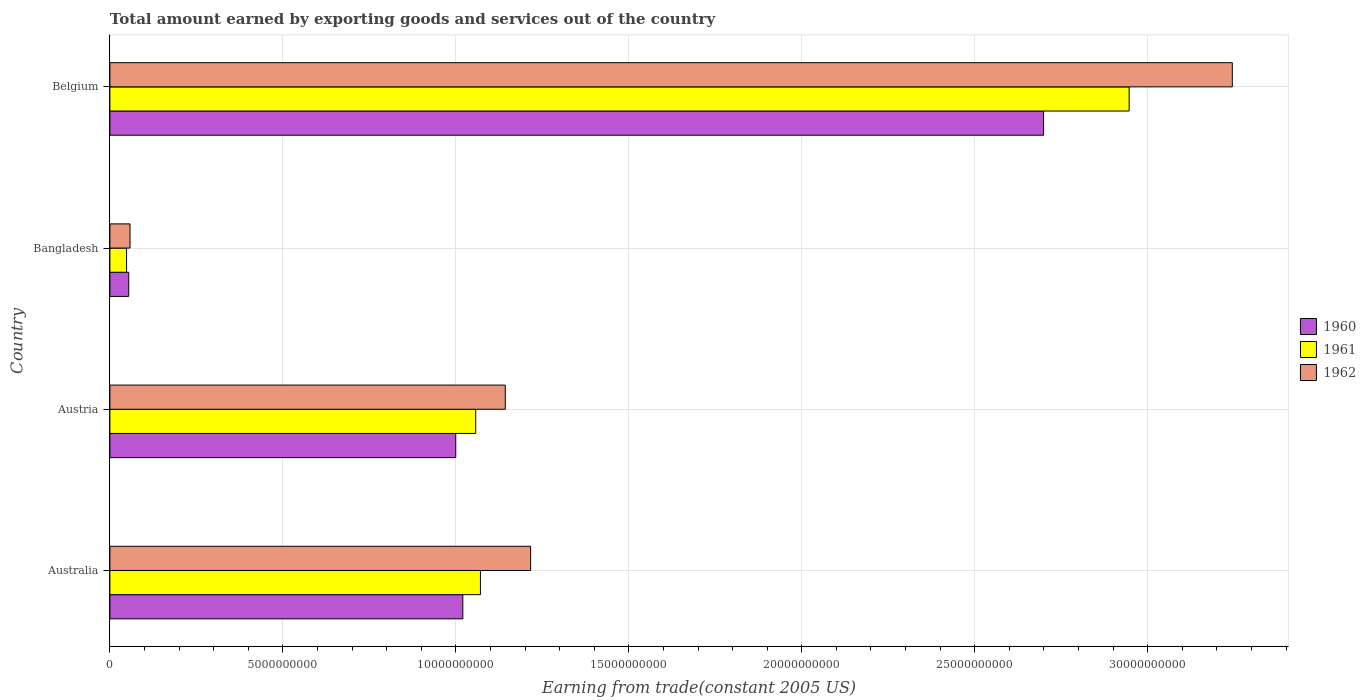How many different coloured bars are there?
Offer a very short reply. 3. How many groups of bars are there?
Give a very brief answer. 4. Are the number of bars on each tick of the Y-axis equal?
Offer a very short reply. Yes. How many bars are there on the 3rd tick from the top?
Your response must be concise. 3. What is the label of the 3rd group of bars from the top?
Your answer should be very brief. Austria. In how many cases, is the number of bars for a given country not equal to the number of legend labels?
Keep it short and to the point. 0. What is the total amount earned by exporting goods and services in 1961 in Australia?
Offer a terse response. 1.07e+1. Across all countries, what is the maximum total amount earned by exporting goods and services in 1961?
Offer a terse response. 2.95e+1. Across all countries, what is the minimum total amount earned by exporting goods and services in 1961?
Ensure brevity in your answer.  4.82e+08. What is the total total amount earned by exporting goods and services in 1962 in the graph?
Your answer should be compact. 5.66e+1. What is the difference between the total amount earned by exporting goods and services in 1962 in Bangladesh and that in Belgium?
Your response must be concise. -3.19e+1. What is the difference between the total amount earned by exporting goods and services in 1960 in Bangladesh and the total amount earned by exporting goods and services in 1962 in Austria?
Your answer should be very brief. -1.09e+1. What is the average total amount earned by exporting goods and services in 1962 per country?
Offer a very short reply. 1.42e+1. What is the difference between the total amount earned by exporting goods and services in 1960 and total amount earned by exporting goods and services in 1961 in Belgium?
Offer a very short reply. -2.47e+09. In how many countries, is the total amount earned by exporting goods and services in 1962 greater than 24000000000 US$?
Offer a terse response. 1. What is the ratio of the total amount earned by exporting goods and services in 1960 in Australia to that in Austria?
Provide a short and direct response. 1.02. What is the difference between the highest and the second highest total amount earned by exporting goods and services in 1961?
Make the answer very short. 1.88e+1. What is the difference between the highest and the lowest total amount earned by exporting goods and services in 1962?
Give a very brief answer. 3.19e+1. What does the 2nd bar from the top in Australia represents?
Provide a short and direct response. 1961. Is it the case that in every country, the sum of the total amount earned by exporting goods and services in 1962 and total amount earned by exporting goods and services in 1961 is greater than the total amount earned by exporting goods and services in 1960?
Your answer should be very brief. Yes. How many bars are there?
Keep it short and to the point. 12. Are all the bars in the graph horizontal?
Your answer should be very brief. Yes. What is the difference between two consecutive major ticks on the X-axis?
Ensure brevity in your answer.  5.00e+09. Are the values on the major ticks of X-axis written in scientific E-notation?
Give a very brief answer. No. Does the graph contain any zero values?
Make the answer very short. No. Does the graph contain grids?
Ensure brevity in your answer.  Yes. Where does the legend appear in the graph?
Your answer should be compact. Center right. How many legend labels are there?
Your answer should be compact. 3. What is the title of the graph?
Make the answer very short. Total amount earned by exporting goods and services out of the country. What is the label or title of the X-axis?
Your answer should be very brief. Earning from trade(constant 2005 US). What is the Earning from trade(constant 2005 US) in 1960 in Australia?
Make the answer very short. 1.02e+1. What is the Earning from trade(constant 2005 US) in 1961 in Australia?
Provide a succinct answer. 1.07e+1. What is the Earning from trade(constant 2005 US) of 1962 in Australia?
Provide a succinct answer. 1.22e+1. What is the Earning from trade(constant 2005 US) in 1960 in Austria?
Provide a succinct answer. 1.00e+1. What is the Earning from trade(constant 2005 US) in 1961 in Austria?
Your answer should be very brief. 1.06e+1. What is the Earning from trade(constant 2005 US) in 1962 in Austria?
Offer a very short reply. 1.14e+1. What is the Earning from trade(constant 2005 US) of 1960 in Bangladesh?
Your answer should be very brief. 5.45e+08. What is the Earning from trade(constant 2005 US) of 1961 in Bangladesh?
Your response must be concise. 4.82e+08. What is the Earning from trade(constant 2005 US) of 1962 in Bangladesh?
Offer a terse response. 5.82e+08. What is the Earning from trade(constant 2005 US) in 1960 in Belgium?
Provide a short and direct response. 2.70e+1. What is the Earning from trade(constant 2005 US) in 1961 in Belgium?
Your answer should be very brief. 2.95e+1. What is the Earning from trade(constant 2005 US) of 1962 in Belgium?
Keep it short and to the point. 3.24e+1. Across all countries, what is the maximum Earning from trade(constant 2005 US) in 1960?
Offer a very short reply. 2.70e+1. Across all countries, what is the maximum Earning from trade(constant 2005 US) in 1961?
Give a very brief answer. 2.95e+1. Across all countries, what is the maximum Earning from trade(constant 2005 US) of 1962?
Offer a very short reply. 3.24e+1. Across all countries, what is the minimum Earning from trade(constant 2005 US) of 1960?
Your answer should be very brief. 5.45e+08. Across all countries, what is the minimum Earning from trade(constant 2005 US) of 1961?
Provide a short and direct response. 4.82e+08. Across all countries, what is the minimum Earning from trade(constant 2005 US) of 1962?
Offer a terse response. 5.82e+08. What is the total Earning from trade(constant 2005 US) of 1960 in the graph?
Your answer should be very brief. 4.77e+1. What is the total Earning from trade(constant 2005 US) of 1961 in the graph?
Give a very brief answer. 5.12e+1. What is the total Earning from trade(constant 2005 US) in 1962 in the graph?
Make the answer very short. 5.66e+1. What is the difference between the Earning from trade(constant 2005 US) in 1960 in Australia and that in Austria?
Your answer should be compact. 2.04e+08. What is the difference between the Earning from trade(constant 2005 US) of 1961 in Australia and that in Austria?
Your response must be concise. 1.36e+08. What is the difference between the Earning from trade(constant 2005 US) of 1962 in Australia and that in Austria?
Your response must be concise. 7.33e+08. What is the difference between the Earning from trade(constant 2005 US) of 1960 in Australia and that in Bangladesh?
Provide a succinct answer. 9.66e+09. What is the difference between the Earning from trade(constant 2005 US) in 1961 in Australia and that in Bangladesh?
Ensure brevity in your answer.  1.02e+1. What is the difference between the Earning from trade(constant 2005 US) of 1962 in Australia and that in Bangladesh?
Make the answer very short. 1.16e+1. What is the difference between the Earning from trade(constant 2005 US) of 1960 in Australia and that in Belgium?
Ensure brevity in your answer.  -1.68e+1. What is the difference between the Earning from trade(constant 2005 US) of 1961 in Australia and that in Belgium?
Offer a very short reply. -1.88e+1. What is the difference between the Earning from trade(constant 2005 US) of 1962 in Australia and that in Belgium?
Your answer should be very brief. -2.03e+1. What is the difference between the Earning from trade(constant 2005 US) of 1960 in Austria and that in Bangladesh?
Give a very brief answer. 9.45e+09. What is the difference between the Earning from trade(constant 2005 US) in 1961 in Austria and that in Bangladesh?
Keep it short and to the point. 1.01e+1. What is the difference between the Earning from trade(constant 2005 US) in 1962 in Austria and that in Bangladesh?
Your answer should be very brief. 1.08e+1. What is the difference between the Earning from trade(constant 2005 US) of 1960 in Austria and that in Belgium?
Give a very brief answer. -1.70e+1. What is the difference between the Earning from trade(constant 2005 US) in 1961 in Austria and that in Belgium?
Keep it short and to the point. -1.89e+1. What is the difference between the Earning from trade(constant 2005 US) of 1962 in Austria and that in Belgium?
Your answer should be very brief. -2.10e+1. What is the difference between the Earning from trade(constant 2005 US) of 1960 in Bangladesh and that in Belgium?
Your answer should be compact. -2.64e+1. What is the difference between the Earning from trade(constant 2005 US) in 1961 in Bangladesh and that in Belgium?
Make the answer very short. -2.90e+1. What is the difference between the Earning from trade(constant 2005 US) of 1962 in Bangladesh and that in Belgium?
Offer a terse response. -3.19e+1. What is the difference between the Earning from trade(constant 2005 US) in 1960 in Australia and the Earning from trade(constant 2005 US) in 1961 in Austria?
Give a very brief answer. -3.73e+08. What is the difference between the Earning from trade(constant 2005 US) in 1960 in Australia and the Earning from trade(constant 2005 US) in 1962 in Austria?
Your answer should be compact. -1.23e+09. What is the difference between the Earning from trade(constant 2005 US) of 1961 in Australia and the Earning from trade(constant 2005 US) of 1962 in Austria?
Keep it short and to the point. -7.18e+08. What is the difference between the Earning from trade(constant 2005 US) in 1960 in Australia and the Earning from trade(constant 2005 US) in 1961 in Bangladesh?
Give a very brief answer. 9.72e+09. What is the difference between the Earning from trade(constant 2005 US) of 1960 in Australia and the Earning from trade(constant 2005 US) of 1962 in Bangladesh?
Provide a short and direct response. 9.62e+09. What is the difference between the Earning from trade(constant 2005 US) in 1961 in Australia and the Earning from trade(constant 2005 US) in 1962 in Bangladesh?
Provide a short and direct response. 1.01e+1. What is the difference between the Earning from trade(constant 2005 US) of 1960 in Australia and the Earning from trade(constant 2005 US) of 1961 in Belgium?
Keep it short and to the point. -1.93e+1. What is the difference between the Earning from trade(constant 2005 US) in 1960 in Australia and the Earning from trade(constant 2005 US) in 1962 in Belgium?
Give a very brief answer. -2.22e+1. What is the difference between the Earning from trade(constant 2005 US) of 1961 in Australia and the Earning from trade(constant 2005 US) of 1962 in Belgium?
Keep it short and to the point. -2.17e+1. What is the difference between the Earning from trade(constant 2005 US) in 1960 in Austria and the Earning from trade(constant 2005 US) in 1961 in Bangladesh?
Keep it short and to the point. 9.52e+09. What is the difference between the Earning from trade(constant 2005 US) of 1960 in Austria and the Earning from trade(constant 2005 US) of 1962 in Bangladesh?
Provide a succinct answer. 9.42e+09. What is the difference between the Earning from trade(constant 2005 US) in 1961 in Austria and the Earning from trade(constant 2005 US) in 1962 in Bangladesh?
Ensure brevity in your answer.  9.99e+09. What is the difference between the Earning from trade(constant 2005 US) of 1960 in Austria and the Earning from trade(constant 2005 US) of 1961 in Belgium?
Give a very brief answer. -1.95e+1. What is the difference between the Earning from trade(constant 2005 US) of 1960 in Austria and the Earning from trade(constant 2005 US) of 1962 in Belgium?
Provide a succinct answer. -2.24e+1. What is the difference between the Earning from trade(constant 2005 US) in 1961 in Austria and the Earning from trade(constant 2005 US) in 1962 in Belgium?
Your answer should be very brief. -2.19e+1. What is the difference between the Earning from trade(constant 2005 US) in 1960 in Bangladesh and the Earning from trade(constant 2005 US) in 1961 in Belgium?
Your response must be concise. -2.89e+1. What is the difference between the Earning from trade(constant 2005 US) of 1960 in Bangladesh and the Earning from trade(constant 2005 US) of 1962 in Belgium?
Offer a very short reply. -3.19e+1. What is the difference between the Earning from trade(constant 2005 US) of 1961 in Bangladesh and the Earning from trade(constant 2005 US) of 1962 in Belgium?
Keep it short and to the point. -3.20e+1. What is the average Earning from trade(constant 2005 US) of 1960 per country?
Offer a terse response. 1.19e+1. What is the average Earning from trade(constant 2005 US) of 1961 per country?
Make the answer very short. 1.28e+1. What is the average Earning from trade(constant 2005 US) in 1962 per country?
Keep it short and to the point. 1.42e+1. What is the difference between the Earning from trade(constant 2005 US) of 1960 and Earning from trade(constant 2005 US) of 1961 in Australia?
Your response must be concise. -5.09e+08. What is the difference between the Earning from trade(constant 2005 US) in 1960 and Earning from trade(constant 2005 US) in 1962 in Australia?
Make the answer very short. -1.96e+09. What is the difference between the Earning from trade(constant 2005 US) of 1961 and Earning from trade(constant 2005 US) of 1962 in Australia?
Your answer should be very brief. -1.45e+09. What is the difference between the Earning from trade(constant 2005 US) in 1960 and Earning from trade(constant 2005 US) in 1961 in Austria?
Offer a very short reply. -5.77e+08. What is the difference between the Earning from trade(constant 2005 US) in 1960 and Earning from trade(constant 2005 US) in 1962 in Austria?
Provide a succinct answer. -1.43e+09. What is the difference between the Earning from trade(constant 2005 US) in 1961 and Earning from trade(constant 2005 US) in 1962 in Austria?
Provide a succinct answer. -8.54e+08. What is the difference between the Earning from trade(constant 2005 US) in 1960 and Earning from trade(constant 2005 US) in 1961 in Bangladesh?
Your answer should be very brief. 6.26e+07. What is the difference between the Earning from trade(constant 2005 US) in 1960 and Earning from trade(constant 2005 US) in 1962 in Bangladesh?
Your answer should be compact. -3.76e+07. What is the difference between the Earning from trade(constant 2005 US) in 1961 and Earning from trade(constant 2005 US) in 1962 in Bangladesh?
Provide a succinct answer. -1.00e+08. What is the difference between the Earning from trade(constant 2005 US) in 1960 and Earning from trade(constant 2005 US) in 1961 in Belgium?
Provide a succinct answer. -2.47e+09. What is the difference between the Earning from trade(constant 2005 US) of 1960 and Earning from trade(constant 2005 US) of 1962 in Belgium?
Your answer should be very brief. -5.46e+09. What is the difference between the Earning from trade(constant 2005 US) in 1961 and Earning from trade(constant 2005 US) in 1962 in Belgium?
Ensure brevity in your answer.  -2.98e+09. What is the ratio of the Earning from trade(constant 2005 US) in 1960 in Australia to that in Austria?
Make the answer very short. 1.02. What is the ratio of the Earning from trade(constant 2005 US) in 1961 in Australia to that in Austria?
Keep it short and to the point. 1.01. What is the ratio of the Earning from trade(constant 2005 US) of 1962 in Australia to that in Austria?
Offer a very short reply. 1.06. What is the ratio of the Earning from trade(constant 2005 US) of 1960 in Australia to that in Bangladesh?
Keep it short and to the point. 18.73. What is the ratio of the Earning from trade(constant 2005 US) in 1961 in Australia to that in Bangladesh?
Provide a short and direct response. 22.23. What is the ratio of the Earning from trade(constant 2005 US) of 1962 in Australia to that in Bangladesh?
Your response must be concise. 20.89. What is the ratio of the Earning from trade(constant 2005 US) in 1960 in Australia to that in Belgium?
Your answer should be very brief. 0.38. What is the ratio of the Earning from trade(constant 2005 US) in 1961 in Australia to that in Belgium?
Keep it short and to the point. 0.36. What is the ratio of the Earning from trade(constant 2005 US) in 1962 in Australia to that in Belgium?
Provide a succinct answer. 0.37. What is the ratio of the Earning from trade(constant 2005 US) in 1960 in Austria to that in Bangladesh?
Give a very brief answer. 18.36. What is the ratio of the Earning from trade(constant 2005 US) in 1961 in Austria to that in Bangladesh?
Provide a succinct answer. 21.94. What is the ratio of the Earning from trade(constant 2005 US) in 1962 in Austria to that in Bangladesh?
Your answer should be very brief. 19.63. What is the ratio of the Earning from trade(constant 2005 US) of 1960 in Austria to that in Belgium?
Keep it short and to the point. 0.37. What is the ratio of the Earning from trade(constant 2005 US) in 1961 in Austria to that in Belgium?
Your answer should be compact. 0.36. What is the ratio of the Earning from trade(constant 2005 US) of 1962 in Austria to that in Belgium?
Ensure brevity in your answer.  0.35. What is the ratio of the Earning from trade(constant 2005 US) in 1960 in Bangladesh to that in Belgium?
Your answer should be compact. 0.02. What is the ratio of the Earning from trade(constant 2005 US) of 1961 in Bangladesh to that in Belgium?
Your answer should be very brief. 0.02. What is the ratio of the Earning from trade(constant 2005 US) of 1962 in Bangladesh to that in Belgium?
Keep it short and to the point. 0.02. What is the difference between the highest and the second highest Earning from trade(constant 2005 US) of 1960?
Offer a very short reply. 1.68e+1. What is the difference between the highest and the second highest Earning from trade(constant 2005 US) of 1961?
Ensure brevity in your answer.  1.88e+1. What is the difference between the highest and the second highest Earning from trade(constant 2005 US) in 1962?
Offer a terse response. 2.03e+1. What is the difference between the highest and the lowest Earning from trade(constant 2005 US) of 1960?
Offer a very short reply. 2.64e+1. What is the difference between the highest and the lowest Earning from trade(constant 2005 US) in 1961?
Offer a very short reply. 2.90e+1. What is the difference between the highest and the lowest Earning from trade(constant 2005 US) of 1962?
Ensure brevity in your answer.  3.19e+1. 